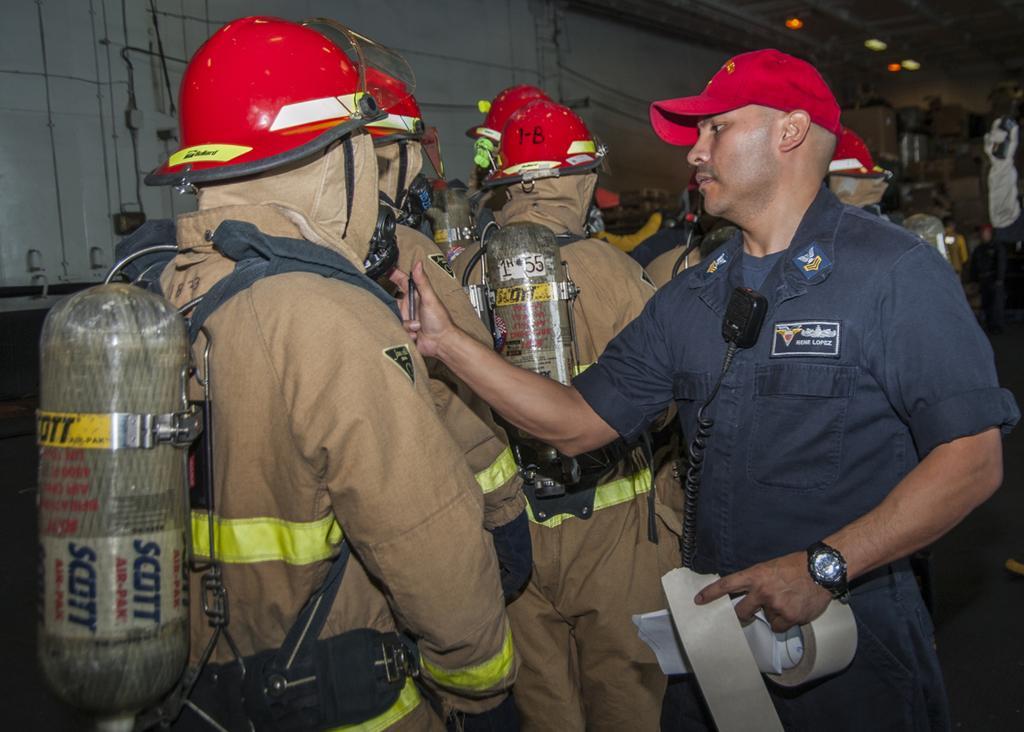Describe this image in one or two sentences. In this picture I can observe some men carrying cylinders on their back. They are wearing red color helmets on their heads. In the background there is wall. 